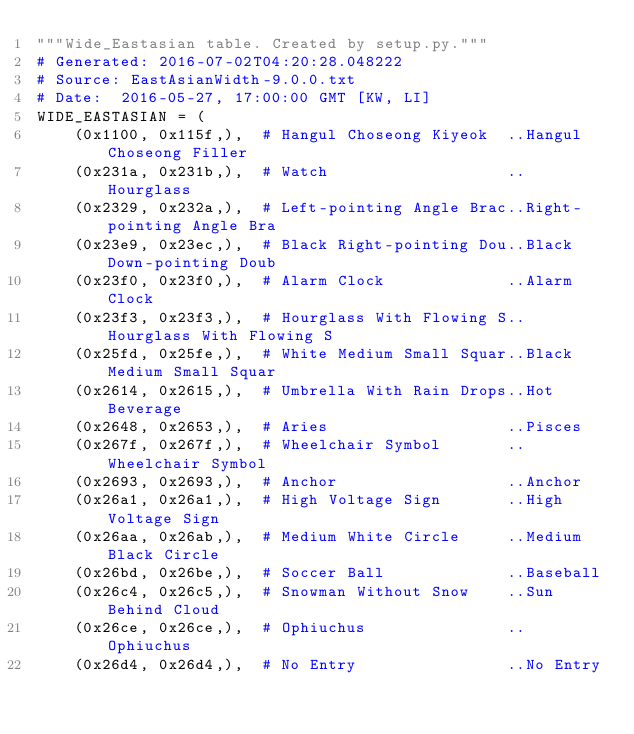Convert code to text. <code><loc_0><loc_0><loc_500><loc_500><_Python_>"""Wide_Eastasian table. Created by setup.py."""
# Generated: 2016-07-02T04:20:28.048222
# Source: EastAsianWidth-9.0.0.txt
# Date:  2016-05-27, 17:00:00 GMT [KW, LI]
WIDE_EASTASIAN = (
    (0x1100, 0x115f,),  # Hangul Choseong Kiyeok  ..Hangul Choseong Filler
    (0x231a, 0x231b,),  # Watch                   ..Hourglass
    (0x2329, 0x232a,),  # Left-pointing Angle Brac..Right-pointing Angle Bra
    (0x23e9, 0x23ec,),  # Black Right-pointing Dou..Black Down-pointing Doub
    (0x23f0, 0x23f0,),  # Alarm Clock             ..Alarm Clock
    (0x23f3, 0x23f3,),  # Hourglass With Flowing S..Hourglass With Flowing S
    (0x25fd, 0x25fe,),  # White Medium Small Squar..Black Medium Small Squar
    (0x2614, 0x2615,),  # Umbrella With Rain Drops..Hot Beverage
    (0x2648, 0x2653,),  # Aries                   ..Pisces
    (0x267f, 0x267f,),  # Wheelchair Symbol       ..Wheelchair Symbol
    (0x2693, 0x2693,),  # Anchor                  ..Anchor
    (0x26a1, 0x26a1,),  # High Voltage Sign       ..High Voltage Sign
    (0x26aa, 0x26ab,),  # Medium White Circle     ..Medium Black Circle
    (0x26bd, 0x26be,),  # Soccer Ball             ..Baseball
    (0x26c4, 0x26c5,),  # Snowman Without Snow    ..Sun Behind Cloud
    (0x26ce, 0x26ce,),  # Ophiuchus               ..Ophiuchus
    (0x26d4, 0x26d4,),  # No Entry                ..No Entry</code> 